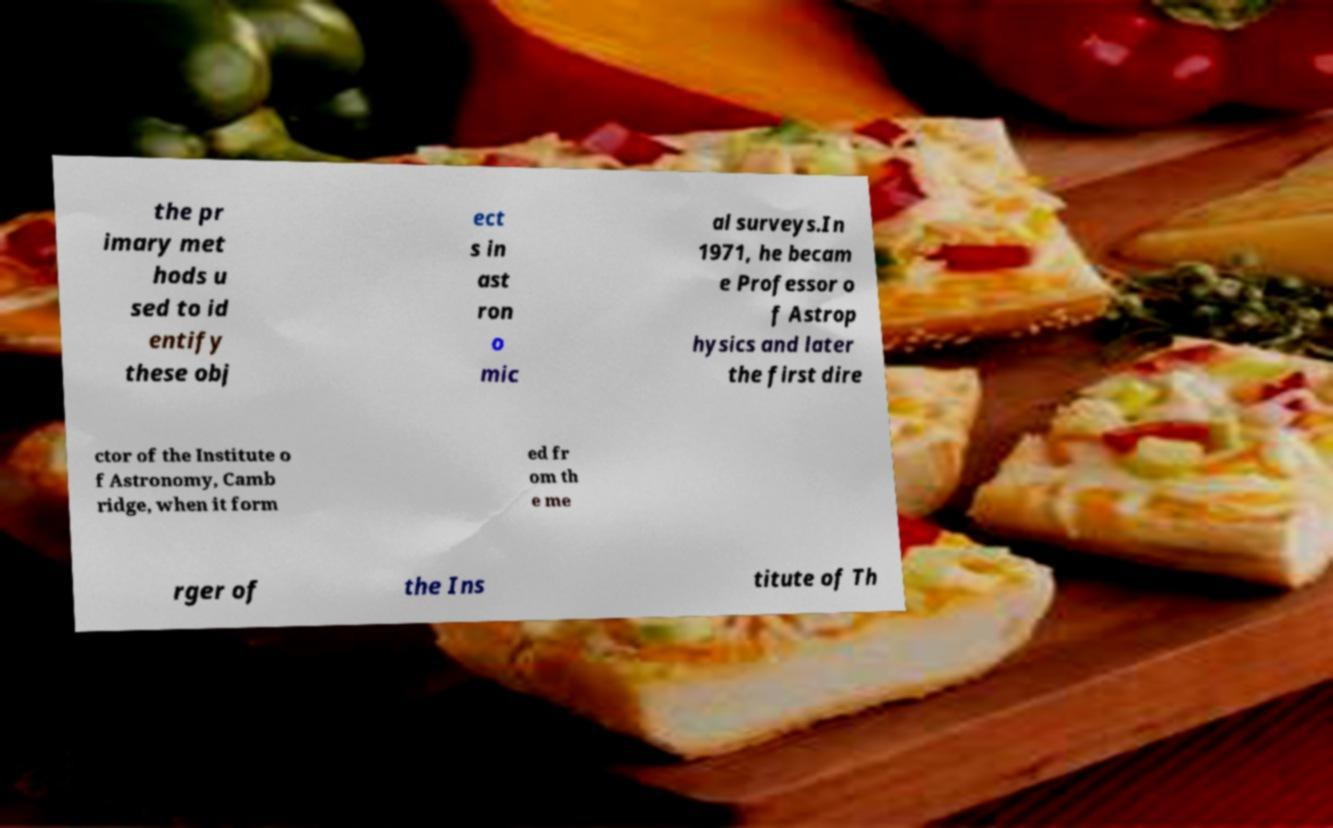Please identify and transcribe the text found in this image. the pr imary met hods u sed to id entify these obj ect s in ast ron o mic al surveys.In 1971, he becam e Professor o f Astrop hysics and later the first dire ctor of the Institute o f Astronomy, Camb ridge, when it form ed fr om th e me rger of the Ins titute of Th 